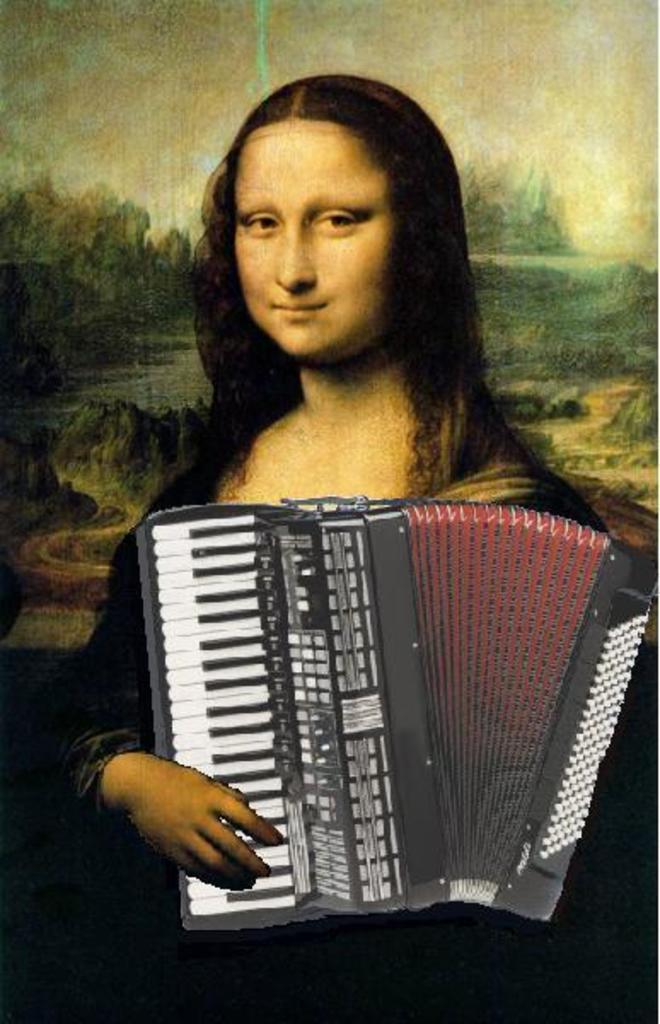Please provide a concise description of this image. There is a monalisa painting. There is a harmonium at the front. 